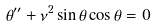Convert formula to latex. <formula><loc_0><loc_0><loc_500><loc_500>\theta ^ { \prime \prime } + \nu ^ { 2 } \sin \theta \cos \theta = 0</formula> 